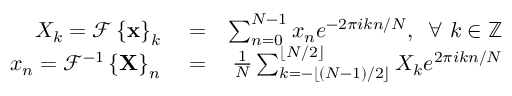Convert formula to latex. <formula><loc_0><loc_0><loc_500><loc_500>\begin{array} { r l r } { X _ { k } = \mathcal { F } \left \{ x \right \} _ { k } } & = } & { \sum _ { n = 0 } ^ { N - 1 } x _ { n } e ^ { - 2 \pi i k n / N } , \, \forall k \in \mathbb { Z } } \\ { x _ { n } = \mathcal { F } ^ { - 1 } \left \{ X \right \} _ { n } } & = } & { \frac { 1 } { N } \sum _ { k = - \lfloor ( N - 1 ) / 2 \rfloor } ^ { \lfloor N / 2 \rfloor } X _ { k } e ^ { 2 \pi i k n / N } } \end{array}</formula> 